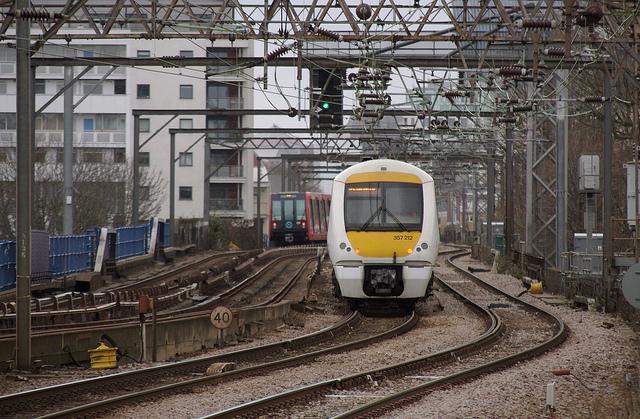How many trains are visible?
Give a very brief answer. 2. How many trains are there?
Give a very brief answer. 2. How many wood chairs are tilted?
Give a very brief answer. 0. 